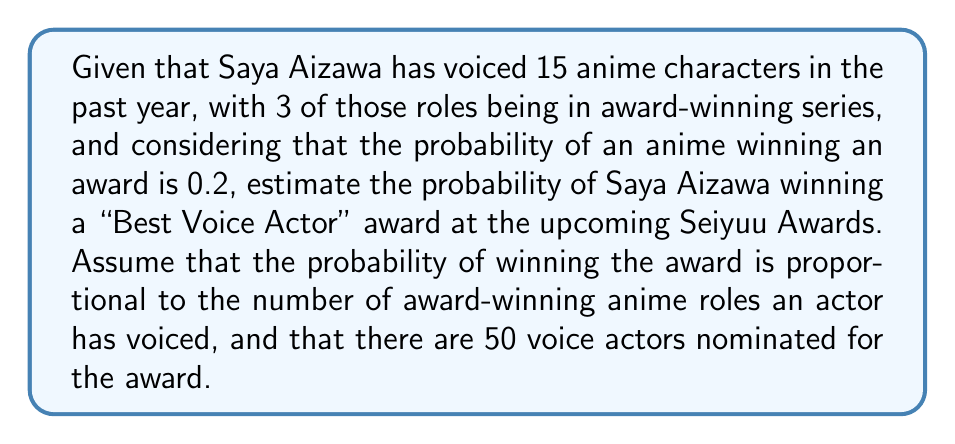Provide a solution to this math problem. Let's approach this step-by-step:

1) First, we need to calculate the expected number of award-winning roles for an average voice actor:
   $$ E(\text{award-winning roles}) = 15 \times 0.2 = 3 $$

2) Saya Aizawa has exactly 3 award-winning roles, which is equal to the expected value.

3) The probability of winning can be modeled as:
   $$ P(\text{winning}) = \frac{\text{number of award-winning roles}}{\text{total number of award-winning roles across all nominees}} $$

4) For Saya Aizawa, we know she has 3 award-winning roles.

5) For all nominees combined:
   $$ \text{Total award-winning roles} = 50 \times 3 = 150 $$
   (assuming each nominee has the average number of award-winning roles)

6) Therefore, the probability of Saya Aizawa winning is:
   $$ P(\text{Saya winning}) = \frac{3}{150} = \frac{1}{50} = 0.02 $$

This calculation assumes a simplified model where only the number of award-winning roles matters, and all other factors (such as performance quality, popularity, etc.) are not considered.
Answer: 0.02 